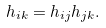<formula> <loc_0><loc_0><loc_500><loc_500>& h _ { i k } = h _ { i j } h _ { j k } .</formula> 